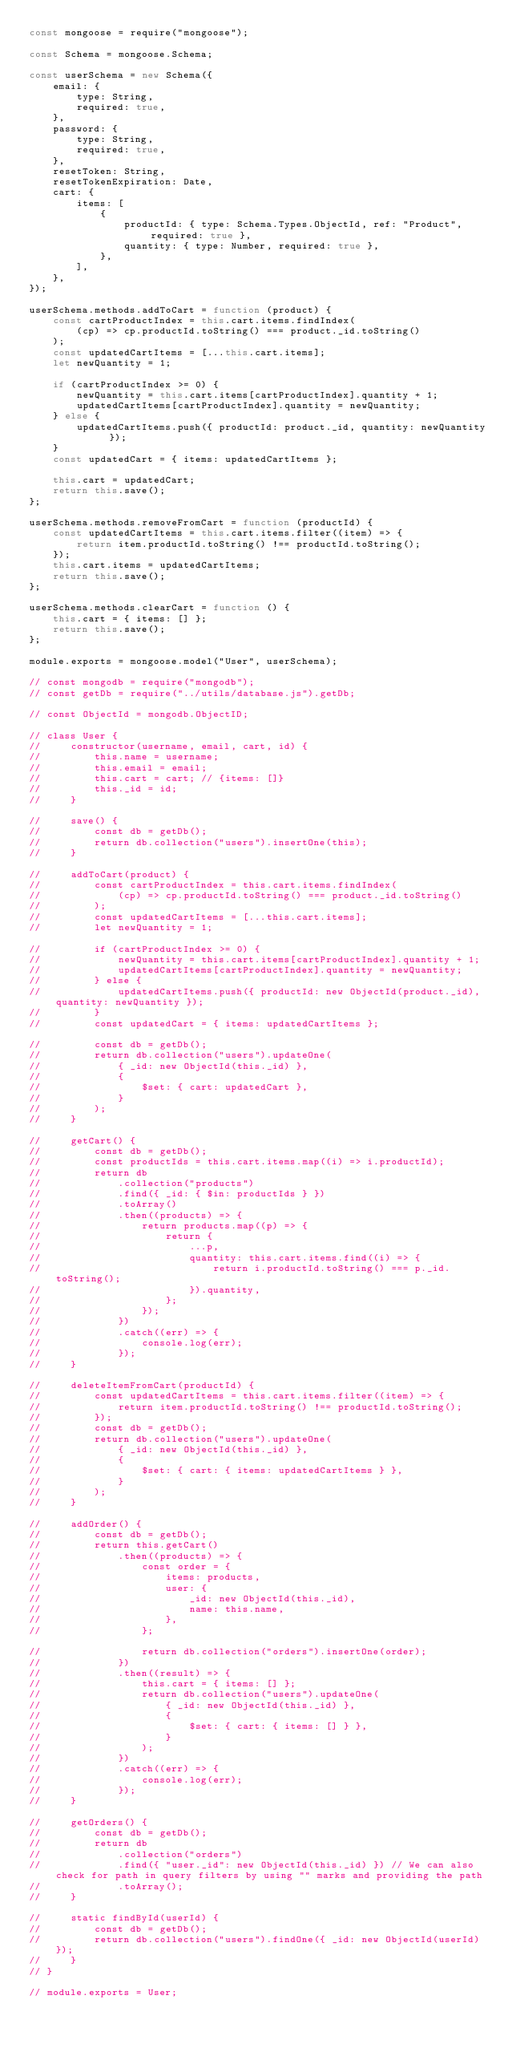<code> <loc_0><loc_0><loc_500><loc_500><_JavaScript_>const mongoose = require("mongoose");

const Schema = mongoose.Schema;

const userSchema = new Schema({
    email: {
        type: String,
        required: true,
    },
    password: {
        type: String,
        required: true,
    },
    resetToken: String,
    resetTokenExpiration: Date,
    cart: {
        items: [
            {
                productId: { type: Schema.Types.ObjectId, ref: "Product", required: true },
                quantity: { type: Number, required: true },
            },
        ],
    },
});

userSchema.methods.addToCart = function (product) {
    const cartProductIndex = this.cart.items.findIndex(
        (cp) => cp.productId.toString() === product._id.toString()
    );
    const updatedCartItems = [...this.cart.items];
    let newQuantity = 1;

    if (cartProductIndex >= 0) {
        newQuantity = this.cart.items[cartProductIndex].quantity + 1;
        updatedCartItems[cartProductIndex].quantity = newQuantity;
    } else {
        updatedCartItems.push({ productId: product._id, quantity: newQuantity });
    }
    const updatedCart = { items: updatedCartItems };

    this.cart = updatedCart;
    return this.save();
};

userSchema.methods.removeFromCart = function (productId) {
    const updatedCartItems = this.cart.items.filter((item) => {
        return item.productId.toString() !== productId.toString();
    });
    this.cart.items = updatedCartItems;
    return this.save();
};

userSchema.methods.clearCart = function () {
    this.cart = { items: [] };
    return this.save();
};

module.exports = mongoose.model("User", userSchema);

// const mongodb = require("mongodb");
// const getDb = require("../utils/database.js").getDb;

// const ObjectId = mongodb.ObjectID;

// class User {
//     constructor(username, email, cart, id) {
//         this.name = username;
//         this.email = email;
//         this.cart = cart; // {items: []}
//         this._id = id;
//     }

//     save() {
//         const db = getDb();
//         return db.collection("users").insertOne(this);
//     }

//     addToCart(product) {
//         const cartProductIndex = this.cart.items.findIndex(
//             (cp) => cp.productId.toString() === product._id.toString()
//         );
//         const updatedCartItems = [...this.cart.items];
//         let newQuantity = 1;

//         if (cartProductIndex >= 0) {
//             newQuantity = this.cart.items[cartProductIndex].quantity + 1;
//             updatedCartItems[cartProductIndex].quantity = newQuantity;
//         } else {
//             updatedCartItems.push({ productId: new ObjectId(product._id), quantity: newQuantity });
//         }
//         const updatedCart = { items: updatedCartItems };

//         const db = getDb();
//         return db.collection("users").updateOne(
//             { _id: new ObjectId(this._id) },
//             {
//                 $set: { cart: updatedCart },
//             }
//         );
//     }

//     getCart() {
//         const db = getDb();
//         const productIds = this.cart.items.map((i) => i.productId);
//         return db
//             .collection("products")
//             .find({ _id: { $in: productIds } })
//             .toArray()
//             .then((products) => {
//                 return products.map((p) => {
//                     return {
//                         ...p,
//                         quantity: this.cart.items.find((i) => {
//                             return i.productId.toString() === p._id.toString();
//                         }).quantity,
//                     };
//                 });
//             })
//             .catch((err) => {
//                 console.log(err);
//             });
//     }

//     deleteItemFromCart(productId) {
//         const updatedCartItems = this.cart.items.filter((item) => {
//             return item.productId.toString() !== productId.toString();
//         });
//         const db = getDb();
//         return db.collection("users").updateOne(
//             { _id: new ObjectId(this._id) },
//             {
//                 $set: { cart: { items: updatedCartItems } },
//             }
//         );
//     }

//     addOrder() {
//         const db = getDb();
//         return this.getCart()
//             .then((products) => {
//                 const order = {
//                     items: products,
//                     user: {
//                         _id: new ObjectId(this._id),
//                         name: this.name,
//                     },
//                 };

//                 return db.collection("orders").insertOne(order);
//             })
//             .then((result) => {
//                 this.cart = { items: [] };
//                 return db.collection("users").updateOne(
//                     { _id: new ObjectId(this._id) },
//                     {
//                         $set: { cart: { items: [] } },
//                     }
//                 );
//             })
//             .catch((err) => {
//                 console.log(err);
//             });
//     }

//     getOrders() {
//         const db = getDb();
//         return db
//             .collection("orders")
//             .find({ "user._id": new ObjectId(this._id) }) // We can also check for path in query filters by using "" marks and providing the path
//             .toArray();
//     }

//     static findById(userId) {
//         const db = getDb();
//         return db.collection("users").findOne({ _id: new ObjectId(userId) });
//     }
// }

// module.exports = User;
</code> 